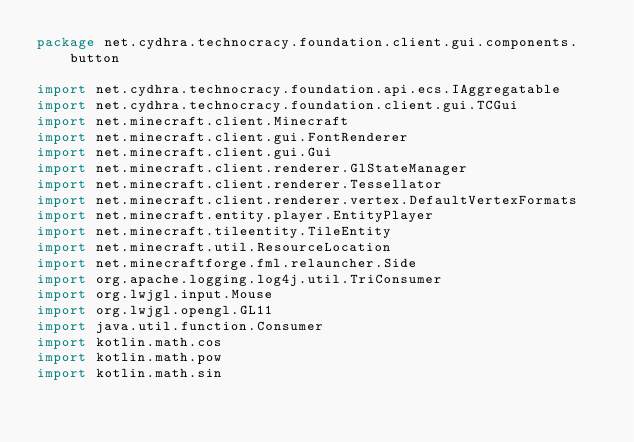Convert code to text. <code><loc_0><loc_0><loc_500><loc_500><_Kotlin_>package net.cydhra.technocracy.foundation.client.gui.components.button

import net.cydhra.technocracy.foundation.api.ecs.IAggregatable
import net.cydhra.technocracy.foundation.client.gui.TCGui
import net.minecraft.client.Minecraft
import net.minecraft.client.gui.FontRenderer
import net.minecraft.client.gui.Gui
import net.minecraft.client.renderer.GlStateManager
import net.minecraft.client.renderer.Tessellator
import net.minecraft.client.renderer.vertex.DefaultVertexFormats
import net.minecraft.entity.player.EntityPlayer
import net.minecraft.tileentity.TileEntity
import net.minecraft.util.ResourceLocation
import net.minecraftforge.fml.relauncher.Side
import org.apache.logging.log4j.util.TriConsumer
import org.lwjgl.input.Mouse
import org.lwjgl.opengl.GL11
import java.util.function.Consumer
import kotlin.math.cos
import kotlin.math.pow
import kotlin.math.sin</code> 